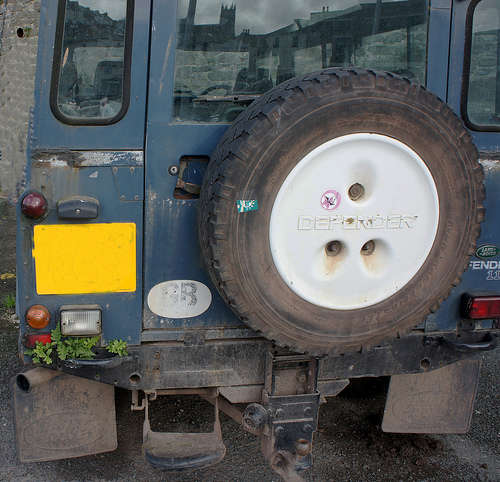<image>
Can you confirm if the spare wheel is behind the car? Yes. From this viewpoint, the spare wheel is positioned behind the car, with the car partially or fully occluding the spare wheel. 